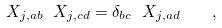Convert formula to latex. <formula><loc_0><loc_0><loc_500><loc_500>X _ { j , a b } \ X _ { j , c d } = \delta _ { b c } \ X _ { j , a d } \quad ,</formula> 